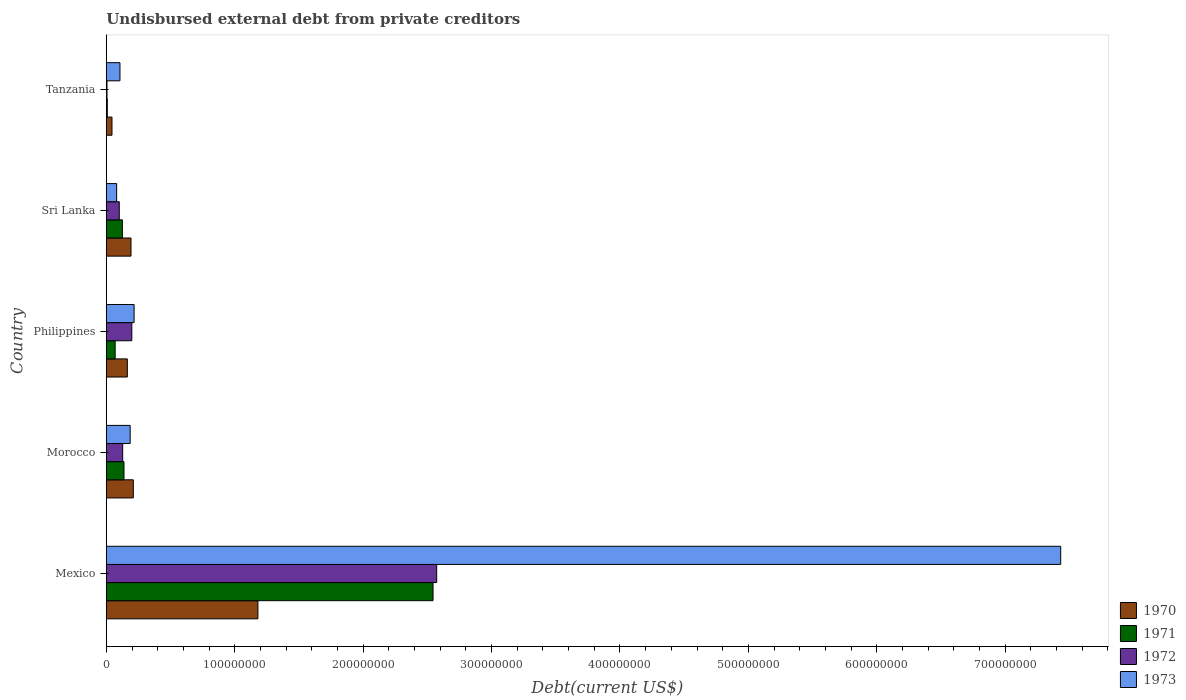Are the number of bars on each tick of the Y-axis equal?
Offer a very short reply. Yes. How many bars are there on the 1st tick from the top?
Make the answer very short. 4. How many bars are there on the 1st tick from the bottom?
Make the answer very short. 4. What is the label of the 4th group of bars from the top?
Provide a short and direct response. Morocco. What is the total debt in 1972 in Mexico?
Offer a very short reply. 2.57e+08. Across all countries, what is the maximum total debt in 1973?
Your answer should be very brief. 7.43e+08. Across all countries, what is the minimum total debt in 1971?
Provide a short and direct response. 7.65e+05. In which country was the total debt in 1970 minimum?
Offer a very short reply. Tanzania. What is the total total debt in 1973 in the graph?
Keep it short and to the point. 8.02e+08. What is the difference between the total debt in 1971 in Morocco and that in Sri Lanka?
Your response must be concise. 1.26e+06. What is the difference between the total debt in 1971 in Morocco and the total debt in 1973 in Sri Lanka?
Offer a terse response. 5.72e+06. What is the average total debt in 1973 per country?
Your answer should be compact. 1.60e+08. What is the difference between the total debt in 1971 and total debt in 1972 in Sri Lanka?
Offer a terse response. 2.42e+06. What is the ratio of the total debt in 1971 in Morocco to that in Philippines?
Provide a short and direct response. 2. Is the total debt in 1970 in Morocco less than that in Tanzania?
Your response must be concise. No. What is the difference between the highest and the second highest total debt in 1973?
Give a very brief answer. 7.22e+08. What is the difference between the highest and the lowest total debt in 1970?
Offer a very short reply. 1.14e+08. In how many countries, is the total debt in 1971 greater than the average total debt in 1971 taken over all countries?
Your response must be concise. 1. Is it the case that in every country, the sum of the total debt in 1973 and total debt in 1971 is greater than the total debt in 1970?
Make the answer very short. Yes. How many bars are there?
Your answer should be very brief. 20. What is the difference between two consecutive major ticks on the X-axis?
Provide a short and direct response. 1.00e+08. Are the values on the major ticks of X-axis written in scientific E-notation?
Offer a very short reply. No. Does the graph contain any zero values?
Give a very brief answer. No. Does the graph contain grids?
Offer a very short reply. No. Where does the legend appear in the graph?
Your answer should be compact. Bottom right. How many legend labels are there?
Your response must be concise. 4. How are the legend labels stacked?
Make the answer very short. Vertical. What is the title of the graph?
Provide a short and direct response. Undisbursed external debt from private creditors. What is the label or title of the X-axis?
Ensure brevity in your answer.  Debt(current US$). What is the label or title of the Y-axis?
Provide a succinct answer. Country. What is the Debt(current US$) of 1970 in Mexico?
Offer a terse response. 1.18e+08. What is the Debt(current US$) of 1971 in Mexico?
Your response must be concise. 2.54e+08. What is the Debt(current US$) of 1972 in Mexico?
Give a very brief answer. 2.57e+08. What is the Debt(current US$) of 1973 in Mexico?
Your response must be concise. 7.43e+08. What is the Debt(current US$) of 1970 in Morocco?
Keep it short and to the point. 2.10e+07. What is the Debt(current US$) of 1971 in Morocco?
Your response must be concise. 1.37e+07. What is the Debt(current US$) of 1972 in Morocco?
Make the answer very short. 1.27e+07. What is the Debt(current US$) of 1973 in Morocco?
Your answer should be very brief. 1.86e+07. What is the Debt(current US$) of 1970 in Philippines?
Keep it short and to the point. 1.64e+07. What is the Debt(current US$) in 1971 in Philippines?
Offer a terse response. 6.87e+06. What is the Debt(current US$) in 1972 in Philippines?
Provide a short and direct response. 1.99e+07. What is the Debt(current US$) of 1973 in Philippines?
Provide a short and direct response. 2.16e+07. What is the Debt(current US$) of 1970 in Sri Lanka?
Keep it short and to the point. 1.92e+07. What is the Debt(current US$) in 1971 in Sri Lanka?
Offer a terse response. 1.25e+07. What is the Debt(current US$) in 1972 in Sri Lanka?
Your answer should be very brief. 1.01e+07. What is the Debt(current US$) of 1973 in Sri Lanka?
Give a very brief answer. 8.03e+06. What is the Debt(current US$) in 1970 in Tanzania?
Make the answer very short. 4.40e+06. What is the Debt(current US$) in 1971 in Tanzania?
Give a very brief answer. 7.65e+05. What is the Debt(current US$) in 1972 in Tanzania?
Your response must be concise. 5.15e+05. What is the Debt(current US$) of 1973 in Tanzania?
Offer a very short reply. 1.06e+07. Across all countries, what is the maximum Debt(current US$) in 1970?
Provide a succinct answer. 1.18e+08. Across all countries, what is the maximum Debt(current US$) of 1971?
Your response must be concise. 2.54e+08. Across all countries, what is the maximum Debt(current US$) of 1972?
Give a very brief answer. 2.57e+08. Across all countries, what is the maximum Debt(current US$) of 1973?
Make the answer very short. 7.43e+08. Across all countries, what is the minimum Debt(current US$) of 1970?
Provide a succinct answer. 4.40e+06. Across all countries, what is the minimum Debt(current US$) of 1971?
Keep it short and to the point. 7.65e+05. Across all countries, what is the minimum Debt(current US$) in 1972?
Offer a terse response. 5.15e+05. Across all countries, what is the minimum Debt(current US$) in 1973?
Your response must be concise. 8.03e+06. What is the total Debt(current US$) in 1970 in the graph?
Your answer should be compact. 1.79e+08. What is the total Debt(current US$) of 1971 in the graph?
Your response must be concise. 2.88e+08. What is the total Debt(current US$) in 1972 in the graph?
Offer a very short reply. 3.00e+08. What is the total Debt(current US$) of 1973 in the graph?
Offer a very short reply. 8.02e+08. What is the difference between the Debt(current US$) in 1970 in Mexico and that in Morocco?
Give a very brief answer. 9.70e+07. What is the difference between the Debt(current US$) of 1971 in Mexico and that in Morocco?
Provide a short and direct response. 2.41e+08. What is the difference between the Debt(current US$) of 1972 in Mexico and that in Morocco?
Provide a succinct answer. 2.45e+08. What is the difference between the Debt(current US$) of 1973 in Mexico and that in Morocco?
Offer a very short reply. 7.25e+08. What is the difference between the Debt(current US$) in 1970 in Mexico and that in Philippines?
Give a very brief answer. 1.02e+08. What is the difference between the Debt(current US$) of 1971 in Mexico and that in Philippines?
Your answer should be very brief. 2.48e+08. What is the difference between the Debt(current US$) in 1972 in Mexico and that in Philippines?
Offer a very short reply. 2.37e+08. What is the difference between the Debt(current US$) in 1973 in Mexico and that in Philippines?
Make the answer very short. 7.22e+08. What is the difference between the Debt(current US$) in 1970 in Mexico and that in Sri Lanka?
Offer a very short reply. 9.88e+07. What is the difference between the Debt(current US$) in 1971 in Mexico and that in Sri Lanka?
Give a very brief answer. 2.42e+08. What is the difference between the Debt(current US$) of 1972 in Mexico and that in Sri Lanka?
Keep it short and to the point. 2.47e+08. What is the difference between the Debt(current US$) in 1973 in Mexico and that in Sri Lanka?
Ensure brevity in your answer.  7.35e+08. What is the difference between the Debt(current US$) of 1970 in Mexico and that in Tanzania?
Your answer should be very brief. 1.14e+08. What is the difference between the Debt(current US$) in 1971 in Mexico and that in Tanzania?
Offer a very short reply. 2.54e+08. What is the difference between the Debt(current US$) of 1972 in Mexico and that in Tanzania?
Provide a short and direct response. 2.57e+08. What is the difference between the Debt(current US$) of 1973 in Mexico and that in Tanzania?
Make the answer very short. 7.33e+08. What is the difference between the Debt(current US$) of 1970 in Morocco and that in Philippines?
Offer a very short reply. 4.66e+06. What is the difference between the Debt(current US$) in 1971 in Morocco and that in Philippines?
Your answer should be very brief. 6.88e+06. What is the difference between the Debt(current US$) of 1972 in Morocco and that in Philippines?
Offer a very short reply. -7.12e+06. What is the difference between the Debt(current US$) in 1973 in Morocco and that in Philippines?
Ensure brevity in your answer.  -3.06e+06. What is the difference between the Debt(current US$) of 1970 in Morocco and that in Sri Lanka?
Give a very brief answer. 1.82e+06. What is the difference between the Debt(current US$) in 1971 in Morocco and that in Sri Lanka?
Give a very brief answer. 1.26e+06. What is the difference between the Debt(current US$) of 1972 in Morocco and that in Sri Lanka?
Offer a terse response. 2.67e+06. What is the difference between the Debt(current US$) of 1973 in Morocco and that in Sri Lanka?
Offer a terse response. 1.05e+07. What is the difference between the Debt(current US$) of 1970 in Morocco and that in Tanzania?
Offer a terse response. 1.66e+07. What is the difference between the Debt(current US$) of 1971 in Morocco and that in Tanzania?
Make the answer very short. 1.30e+07. What is the difference between the Debt(current US$) of 1972 in Morocco and that in Tanzania?
Make the answer very short. 1.22e+07. What is the difference between the Debt(current US$) of 1973 in Morocco and that in Tanzania?
Ensure brevity in your answer.  7.94e+06. What is the difference between the Debt(current US$) of 1970 in Philippines and that in Sri Lanka?
Give a very brief answer. -2.85e+06. What is the difference between the Debt(current US$) in 1971 in Philippines and that in Sri Lanka?
Keep it short and to the point. -5.62e+06. What is the difference between the Debt(current US$) of 1972 in Philippines and that in Sri Lanka?
Offer a very short reply. 9.78e+06. What is the difference between the Debt(current US$) of 1973 in Philippines and that in Sri Lanka?
Your answer should be very brief. 1.36e+07. What is the difference between the Debt(current US$) of 1970 in Philippines and that in Tanzania?
Your response must be concise. 1.20e+07. What is the difference between the Debt(current US$) of 1971 in Philippines and that in Tanzania?
Your answer should be compact. 6.11e+06. What is the difference between the Debt(current US$) in 1972 in Philippines and that in Tanzania?
Offer a terse response. 1.93e+07. What is the difference between the Debt(current US$) of 1973 in Philippines and that in Tanzania?
Provide a succinct answer. 1.10e+07. What is the difference between the Debt(current US$) of 1970 in Sri Lanka and that in Tanzania?
Make the answer very short. 1.48e+07. What is the difference between the Debt(current US$) in 1971 in Sri Lanka and that in Tanzania?
Keep it short and to the point. 1.17e+07. What is the difference between the Debt(current US$) in 1972 in Sri Lanka and that in Tanzania?
Ensure brevity in your answer.  9.56e+06. What is the difference between the Debt(current US$) of 1973 in Sri Lanka and that in Tanzania?
Provide a succinct answer. -2.59e+06. What is the difference between the Debt(current US$) of 1970 in Mexico and the Debt(current US$) of 1971 in Morocco?
Your answer should be very brief. 1.04e+08. What is the difference between the Debt(current US$) of 1970 in Mexico and the Debt(current US$) of 1972 in Morocco?
Your answer should be compact. 1.05e+08. What is the difference between the Debt(current US$) of 1970 in Mexico and the Debt(current US$) of 1973 in Morocco?
Provide a short and direct response. 9.95e+07. What is the difference between the Debt(current US$) in 1971 in Mexico and the Debt(current US$) in 1972 in Morocco?
Ensure brevity in your answer.  2.42e+08. What is the difference between the Debt(current US$) in 1971 in Mexico and the Debt(current US$) in 1973 in Morocco?
Your response must be concise. 2.36e+08. What is the difference between the Debt(current US$) in 1972 in Mexico and the Debt(current US$) in 1973 in Morocco?
Provide a short and direct response. 2.39e+08. What is the difference between the Debt(current US$) in 1970 in Mexico and the Debt(current US$) in 1971 in Philippines?
Keep it short and to the point. 1.11e+08. What is the difference between the Debt(current US$) in 1970 in Mexico and the Debt(current US$) in 1972 in Philippines?
Provide a short and direct response. 9.82e+07. What is the difference between the Debt(current US$) of 1970 in Mexico and the Debt(current US$) of 1973 in Philippines?
Give a very brief answer. 9.64e+07. What is the difference between the Debt(current US$) of 1971 in Mexico and the Debt(current US$) of 1972 in Philippines?
Provide a succinct answer. 2.35e+08. What is the difference between the Debt(current US$) of 1971 in Mexico and the Debt(current US$) of 1973 in Philippines?
Make the answer very short. 2.33e+08. What is the difference between the Debt(current US$) in 1972 in Mexico and the Debt(current US$) in 1973 in Philippines?
Ensure brevity in your answer.  2.36e+08. What is the difference between the Debt(current US$) in 1970 in Mexico and the Debt(current US$) in 1971 in Sri Lanka?
Offer a terse response. 1.06e+08. What is the difference between the Debt(current US$) of 1970 in Mexico and the Debt(current US$) of 1972 in Sri Lanka?
Your answer should be compact. 1.08e+08. What is the difference between the Debt(current US$) of 1970 in Mexico and the Debt(current US$) of 1973 in Sri Lanka?
Make the answer very short. 1.10e+08. What is the difference between the Debt(current US$) in 1971 in Mexico and the Debt(current US$) in 1972 in Sri Lanka?
Make the answer very short. 2.44e+08. What is the difference between the Debt(current US$) of 1971 in Mexico and the Debt(current US$) of 1973 in Sri Lanka?
Provide a short and direct response. 2.46e+08. What is the difference between the Debt(current US$) of 1972 in Mexico and the Debt(current US$) of 1973 in Sri Lanka?
Offer a very short reply. 2.49e+08. What is the difference between the Debt(current US$) of 1970 in Mexico and the Debt(current US$) of 1971 in Tanzania?
Give a very brief answer. 1.17e+08. What is the difference between the Debt(current US$) in 1970 in Mexico and the Debt(current US$) in 1972 in Tanzania?
Your answer should be very brief. 1.18e+08. What is the difference between the Debt(current US$) in 1970 in Mexico and the Debt(current US$) in 1973 in Tanzania?
Keep it short and to the point. 1.07e+08. What is the difference between the Debt(current US$) of 1971 in Mexico and the Debt(current US$) of 1972 in Tanzania?
Make the answer very short. 2.54e+08. What is the difference between the Debt(current US$) of 1971 in Mexico and the Debt(current US$) of 1973 in Tanzania?
Your answer should be very brief. 2.44e+08. What is the difference between the Debt(current US$) of 1972 in Mexico and the Debt(current US$) of 1973 in Tanzania?
Keep it short and to the point. 2.47e+08. What is the difference between the Debt(current US$) of 1970 in Morocco and the Debt(current US$) of 1971 in Philippines?
Ensure brevity in your answer.  1.41e+07. What is the difference between the Debt(current US$) in 1970 in Morocco and the Debt(current US$) in 1972 in Philippines?
Your answer should be very brief. 1.16e+06. What is the difference between the Debt(current US$) in 1970 in Morocco and the Debt(current US$) in 1973 in Philippines?
Provide a succinct answer. -6.03e+05. What is the difference between the Debt(current US$) in 1971 in Morocco and the Debt(current US$) in 1972 in Philippines?
Your response must be concise. -6.10e+06. What is the difference between the Debt(current US$) of 1971 in Morocco and the Debt(current US$) of 1973 in Philippines?
Your answer should be compact. -7.87e+06. What is the difference between the Debt(current US$) in 1972 in Morocco and the Debt(current US$) in 1973 in Philippines?
Your response must be concise. -8.88e+06. What is the difference between the Debt(current US$) in 1970 in Morocco and the Debt(current US$) in 1971 in Sri Lanka?
Provide a short and direct response. 8.52e+06. What is the difference between the Debt(current US$) of 1970 in Morocco and the Debt(current US$) of 1972 in Sri Lanka?
Give a very brief answer. 1.09e+07. What is the difference between the Debt(current US$) of 1970 in Morocco and the Debt(current US$) of 1973 in Sri Lanka?
Your response must be concise. 1.30e+07. What is the difference between the Debt(current US$) in 1971 in Morocco and the Debt(current US$) in 1972 in Sri Lanka?
Your answer should be compact. 3.68e+06. What is the difference between the Debt(current US$) of 1971 in Morocco and the Debt(current US$) of 1973 in Sri Lanka?
Provide a short and direct response. 5.72e+06. What is the difference between the Debt(current US$) in 1972 in Morocco and the Debt(current US$) in 1973 in Sri Lanka?
Offer a terse response. 4.71e+06. What is the difference between the Debt(current US$) in 1970 in Morocco and the Debt(current US$) in 1971 in Tanzania?
Offer a very short reply. 2.02e+07. What is the difference between the Debt(current US$) in 1970 in Morocco and the Debt(current US$) in 1972 in Tanzania?
Make the answer very short. 2.05e+07. What is the difference between the Debt(current US$) of 1970 in Morocco and the Debt(current US$) of 1973 in Tanzania?
Your response must be concise. 1.04e+07. What is the difference between the Debt(current US$) of 1971 in Morocco and the Debt(current US$) of 1972 in Tanzania?
Keep it short and to the point. 1.32e+07. What is the difference between the Debt(current US$) in 1971 in Morocco and the Debt(current US$) in 1973 in Tanzania?
Offer a terse response. 3.13e+06. What is the difference between the Debt(current US$) in 1972 in Morocco and the Debt(current US$) in 1973 in Tanzania?
Your answer should be very brief. 2.12e+06. What is the difference between the Debt(current US$) of 1970 in Philippines and the Debt(current US$) of 1971 in Sri Lanka?
Give a very brief answer. 3.86e+06. What is the difference between the Debt(current US$) of 1970 in Philippines and the Debt(current US$) of 1972 in Sri Lanka?
Provide a succinct answer. 6.28e+06. What is the difference between the Debt(current US$) of 1970 in Philippines and the Debt(current US$) of 1973 in Sri Lanka?
Ensure brevity in your answer.  8.32e+06. What is the difference between the Debt(current US$) in 1971 in Philippines and the Debt(current US$) in 1972 in Sri Lanka?
Offer a very short reply. -3.20e+06. What is the difference between the Debt(current US$) of 1971 in Philippines and the Debt(current US$) of 1973 in Sri Lanka?
Offer a terse response. -1.16e+06. What is the difference between the Debt(current US$) in 1972 in Philippines and the Debt(current US$) in 1973 in Sri Lanka?
Your answer should be compact. 1.18e+07. What is the difference between the Debt(current US$) in 1970 in Philippines and the Debt(current US$) in 1971 in Tanzania?
Your answer should be very brief. 1.56e+07. What is the difference between the Debt(current US$) of 1970 in Philippines and the Debt(current US$) of 1972 in Tanzania?
Keep it short and to the point. 1.58e+07. What is the difference between the Debt(current US$) in 1970 in Philippines and the Debt(current US$) in 1973 in Tanzania?
Provide a short and direct response. 5.74e+06. What is the difference between the Debt(current US$) in 1971 in Philippines and the Debt(current US$) in 1972 in Tanzania?
Ensure brevity in your answer.  6.36e+06. What is the difference between the Debt(current US$) in 1971 in Philippines and the Debt(current US$) in 1973 in Tanzania?
Your answer should be compact. -3.74e+06. What is the difference between the Debt(current US$) of 1972 in Philippines and the Debt(current US$) of 1973 in Tanzania?
Offer a very short reply. 9.24e+06. What is the difference between the Debt(current US$) in 1970 in Sri Lanka and the Debt(current US$) in 1971 in Tanzania?
Give a very brief answer. 1.84e+07. What is the difference between the Debt(current US$) in 1970 in Sri Lanka and the Debt(current US$) in 1972 in Tanzania?
Offer a terse response. 1.87e+07. What is the difference between the Debt(current US$) of 1970 in Sri Lanka and the Debt(current US$) of 1973 in Tanzania?
Your response must be concise. 8.58e+06. What is the difference between the Debt(current US$) in 1971 in Sri Lanka and the Debt(current US$) in 1972 in Tanzania?
Offer a terse response. 1.20e+07. What is the difference between the Debt(current US$) of 1971 in Sri Lanka and the Debt(current US$) of 1973 in Tanzania?
Your response must be concise. 1.87e+06. What is the difference between the Debt(current US$) in 1972 in Sri Lanka and the Debt(current US$) in 1973 in Tanzania?
Make the answer very short. -5.46e+05. What is the average Debt(current US$) in 1970 per country?
Your answer should be compact. 3.58e+07. What is the average Debt(current US$) in 1971 per country?
Make the answer very short. 5.77e+07. What is the average Debt(current US$) in 1972 per country?
Give a very brief answer. 6.01e+07. What is the average Debt(current US$) in 1973 per country?
Your answer should be compact. 1.60e+08. What is the difference between the Debt(current US$) of 1970 and Debt(current US$) of 1971 in Mexico?
Give a very brief answer. -1.36e+08. What is the difference between the Debt(current US$) of 1970 and Debt(current US$) of 1972 in Mexico?
Offer a terse response. -1.39e+08. What is the difference between the Debt(current US$) of 1970 and Debt(current US$) of 1973 in Mexico?
Provide a short and direct response. -6.25e+08. What is the difference between the Debt(current US$) of 1971 and Debt(current US$) of 1972 in Mexico?
Provide a succinct answer. -2.84e+06. What is the difference between the Debt(current US$) of 1971 and Debt(current US$) of 1973 in Mexico?
Make the answer very short. -4.89e+08. What is the difference between the Debt(current US$) of 1972 and Debt(current US$) of 1973 in Mexico?
Your response must be concise. -4.86e+08. What is the difference between the Debt(current US$) in 1970 and Debt(current US$) in 1971 in Morocco?
Offer a terse response. 7.27e+06. What is the difference between the Debt(current US$) in 1970 and Debt(current US$) in 1972 in Morocco?
Your answer should be compact. 8.28e+06. What is the difference between the Debt(current US$) in 1970 and Debt(current US$) in 1973 in Morocco?
Your answer should be compact. 2.45e+06. What is the difference between the Debt(current US$) of 1971 and Debt(current US$) of 1972 in Morocco?
Your answer should be very brief. 1.01e+06. What is the difference between the Debt(current US$) of 1971 and Debt(current US$) of 1973 in Morocco?
Your answer should be compact. -4.81e+06. What is the difference between the Debt(current US$) of 1972 and Debt(current US$) of 1973 in Morocco?
Your answer should be very brief. -5.82e+06. What is the difference between the Debt(current US$) of 1970 and Debt(current US$) of 1971 in Philippines?
Keep it short and to the point. 9.48e+06. What is the difference between the Debt(current US$) in 1970 and Debt(current US$) in 1972 in Philippines?
Provide a succinct answer. -3.50e+06. What is the difference between the Debt(current US$) in 1970 and Debt(current US$) in 1973 in Philippines?
Keep it short and to the point. -5.27e+06. What is the difference between the Debt(current US$) in 1971 and Debt(current US$) in 1972 in Philippines?
Ensure brevity in your answer.  -1.30e+07. What is the difference between the Debt(current US$) of 1971 and Debt(current US$) of 1973 in Philippines?
Keep it short and to the point. -1.47e+07. What is the difference between the Debt(current US$) of 1972 and Debt(current US$) of 1973 in Philippines?
Your response must be concise. -1.76e+06. What is the difference between the Debt(current US$) of 1970 and Debt(current US$) of 1971 in Sri Lanka?
Provide a succinct answer. 6.71e+06. What is the difference between the Debt(current US$) of 1970 and Debt(current US$) of 1972 in Sri Lanka?
Provide a succinct answer. 9.13e+06. What is the difference between the Debt(current US$) of 1970 and Debt(current US$) of 1973 in Sri Lanka?
Your response must be concise. 1.12e+07. What is the difference between the Debt(current US$) in 1971 and Debt(current US$) in 1972 in Sri Lanka?
Provide a succinct answer. 2.42e+06. What is the difference between the Debt(current US$) in 1971 and Debt(current US$) in 1973 in Sri Lanka?
Your answer should be very brief. 4.46e+06. What is the difference between the Debt(current US$) in 1972 and Debt(current US$) in 1973 in Sri Lanka?
Provide a short and direct response. 2.04e+06. What is the difference between the Debt(current US$) of 1970 and Debt(current US$) of 1971 in Tanzania?
Your answer should be compact. 3.64e+06. What is the difference between the Debt(current US$) of 1970 and Debt(current US$) of 1972 in Tanzania?
Provide a short and direct response. 3.88e+06. What is the difference between the Debt(current US$) of 1970 and Debt(current US$) of 1973 in Tanzania?
Keep it short and to the point. -6.22e+06. What is the difference between the Debt(current US$) in 1971 and Debt(current US$) in 1973 in Tanzania?
Make the answer very short. -9.85e+06. What is the difference between the Debt(current US$) in 1972 and Debt(current US$) in 1973 in Tanzania?
Provide a succinct answer. -1.01e+07. What is the ratio of the Debt(current US$) in 1970 in Mexico to that in Morocco?
Your answer should be compact. 5.62. What is the ratio of the Debt(current US$) in 1971 in Mexico to that in Morocco?
Ensure brevity in your answer.  18.51. What is the ratio of the Debt(current US$) of 1972 in Mexico to that in Morocco?
Provide a succinct answer. 20.2. What is the ratio of the Debt(current US$) in 1973 in Mexico to that in Morocco?
Offer a terse response. 40.04. What is the ratio of the Debt(current US$) in 1970 in Mexico to that in Philippines?
Provide a succinct answer. 7.22. What is the ratio of the Debt(current US$) in 1971 in Mexico to that in Philippines?
Your answer should be very brief. 37.02. What is the ratio of the Debt(current US$) in 1972 in Mexico to that in Philippines?
Provide a succinct answer. 12.96. What is the ratio of the Debt(current US$) of 1973 in Mexico to that in Philippines?
Your response must be concise. 34.38. What is the ratio of the Debt(current US$) of 1970 in Mexico to that in Sri Lanka?
Give a very brief answer. 6.15. What is the ratio of the Debt(current US$) in 1971 in Mexico to that in Sri Lanka?
Offer a very short reply. 20.37. What is the ratio of the Debt(current US$) of 1972 in Mexico to that in Sri Lanka?
Ensure brevity in your answer.  25.55. What is the ratio of the Debt(current US$) in 1973 in Mexico to that in Sri Lanka?
Your answer should be very brief. 92.59. What is the ratio of the Debt(current US$) of 1970 in Mexico to that in Tanzania?
Ensure brevity in your answer.  26.83. What is the ratio of the Debt(current US$) of 1971 in Mexico to that in Tanzania?
Provide a short and direct response. 332.59. What is the ratio of the Debt(current US$) of 1972 in Mexico to that in Tanzania?
Give a very brief answer. 499.54. What is the ratio of the Debt(current US$) in 1973 in Mexico to that in Tanzania?
Make the answer very short. 70.01. What is the ratio of the Debt(current US$) in 1970 in Morocco to that in Philippines?
Provide a succinct answer. 1.29. What is the ratio of the Debt(current US$) in 1971 in Morocco to that in Philippines?
Provide a short and direct response. 2. What is the ratio of the Debt(current US$) of 1972 in Morocco to that in Philippines?
Ensure brevity in your answer.  0.64. What is the ratio of the Debt(current US$) in 1973 in Morocco to that in Philippines?
Ensure brevity in your answer.  0.86. What is the ratio of the Debt(current US$) in 1970 in Morocco to that in Sri Lanka?
Provide a short and direct response. 1.09. What is the ratio of the Debt(current US$) of 1971 in Morocco to that in Sri Lanka?
Your answer should be very brief. 1.1. What is the ratio of the Debt(current US$) in 1972 in Morocco to that in Sri Lanka?
Provide a succinct answer. 1.26. What is the ratio of the Debt(current US$) in 1973 in Morocco to that in Sri Lanka?
Provide a short and direct response. 2.31. What is the ratio of the Debt(current US$) in 1970 in Morocco to that in Tanzania?
Offer a very short reply. 4.78. What is the ratio of the Debt(current US$) of 1971 in Morocco to that in Tanzania?
Give a very brief answer. 17.97. What is the ratio of the Debt(current US$) in 1972 in Morocco to that in Tanzania?
Make the answer very short. 24.73. What is the ratio of the Debt(current US$) of 1973 in Morocco to that in Tanzania?
Offer a very short reply. 1.75. What is the ratio of the Debt(current US$) of 1970 in Philippines to that in Sri Lanka?
Ensure brevity in your answer.  0.85. What is the ratio of the Debt(current US$) in 1971 in Philippines to that in Sri Lanka?
Your answer should be very brief. 0.55. What is the ratio of the Debt(current US$) of 1972 in Philippines to that in Sri Lanka?
Keep it short and to the point. 1.97. What is the ratio of the Debt(current US$) of 1973 in Philippines to that in Sri Lanka?
Your answer should be very brief. 2.69. What is the ratio of the Debt(current US$) in 1970 in Philippines to that in Tanzania?
Provide a succinct answer. 3.72. What is the ratio of the Debt(current US$) of 1971 in Philippines to that in Tanzania?
Your response must be concise. 8.98. What is the ratio of the Debt(current US$) in 1972 in Philippines to that in Tanzania?
Provide a succinct answer. 38.55. What is the ratio of the Debt(current US$) in 1973 in Philippines to that in Tanzania?
Make the answer very short. 2.04. What is the ratio of the Debt(current US$) in 1970 in Sri Lanka to that in Tanzania?
Keep it short and to the point. 4.36. What is the ratio of the Debt(current US$) in 1971 in Sri Lanka to that in Tanzania?
Offer a very short reply. 16.33. What is the ratio of the Debt(current US$) of 1972 in Sri Lanka to that in Tanzania?
Give a very brief answer. 19.55. What is the ratio of the Debt(current US$) of 1973 in Sri Lanka to that in Tanzania?
Make the answer very short. 0.76. What is the difference between the highest and the second highest Debt(current US$) of 1970?
Provide a short and direct response. 9.70e+07. What is the difference between the highest and the second highest Debt(current US$) in 1971?
Offer a very short reply. 2.41e+08. What is the difference between the highest and the second highest Debt(current US$) of 1972?
Provide a short and direct response. 2.37e+08. What is the difference between the highest and the second highest Debt(current US$) in 1973?
Your answer should be very brief. 7.22e+08. What is the difference between the highest and the lowest Debt(current US$) of 1970?
Make the answer very short. 1.14e+08. What is the difference between the highest and the lowest Debt(current US$) in 1971?
Your answer should be compact. 2.54e+08. What is the difference between the highest and the lowest Debt(current US$) of 1972?
Ensure brevity in your answer.  2.57e+08. What is the difference between the highest and the lowest Debt(current US$) in 1973?
Ensure brevity in your answer.  7.35e+08. 